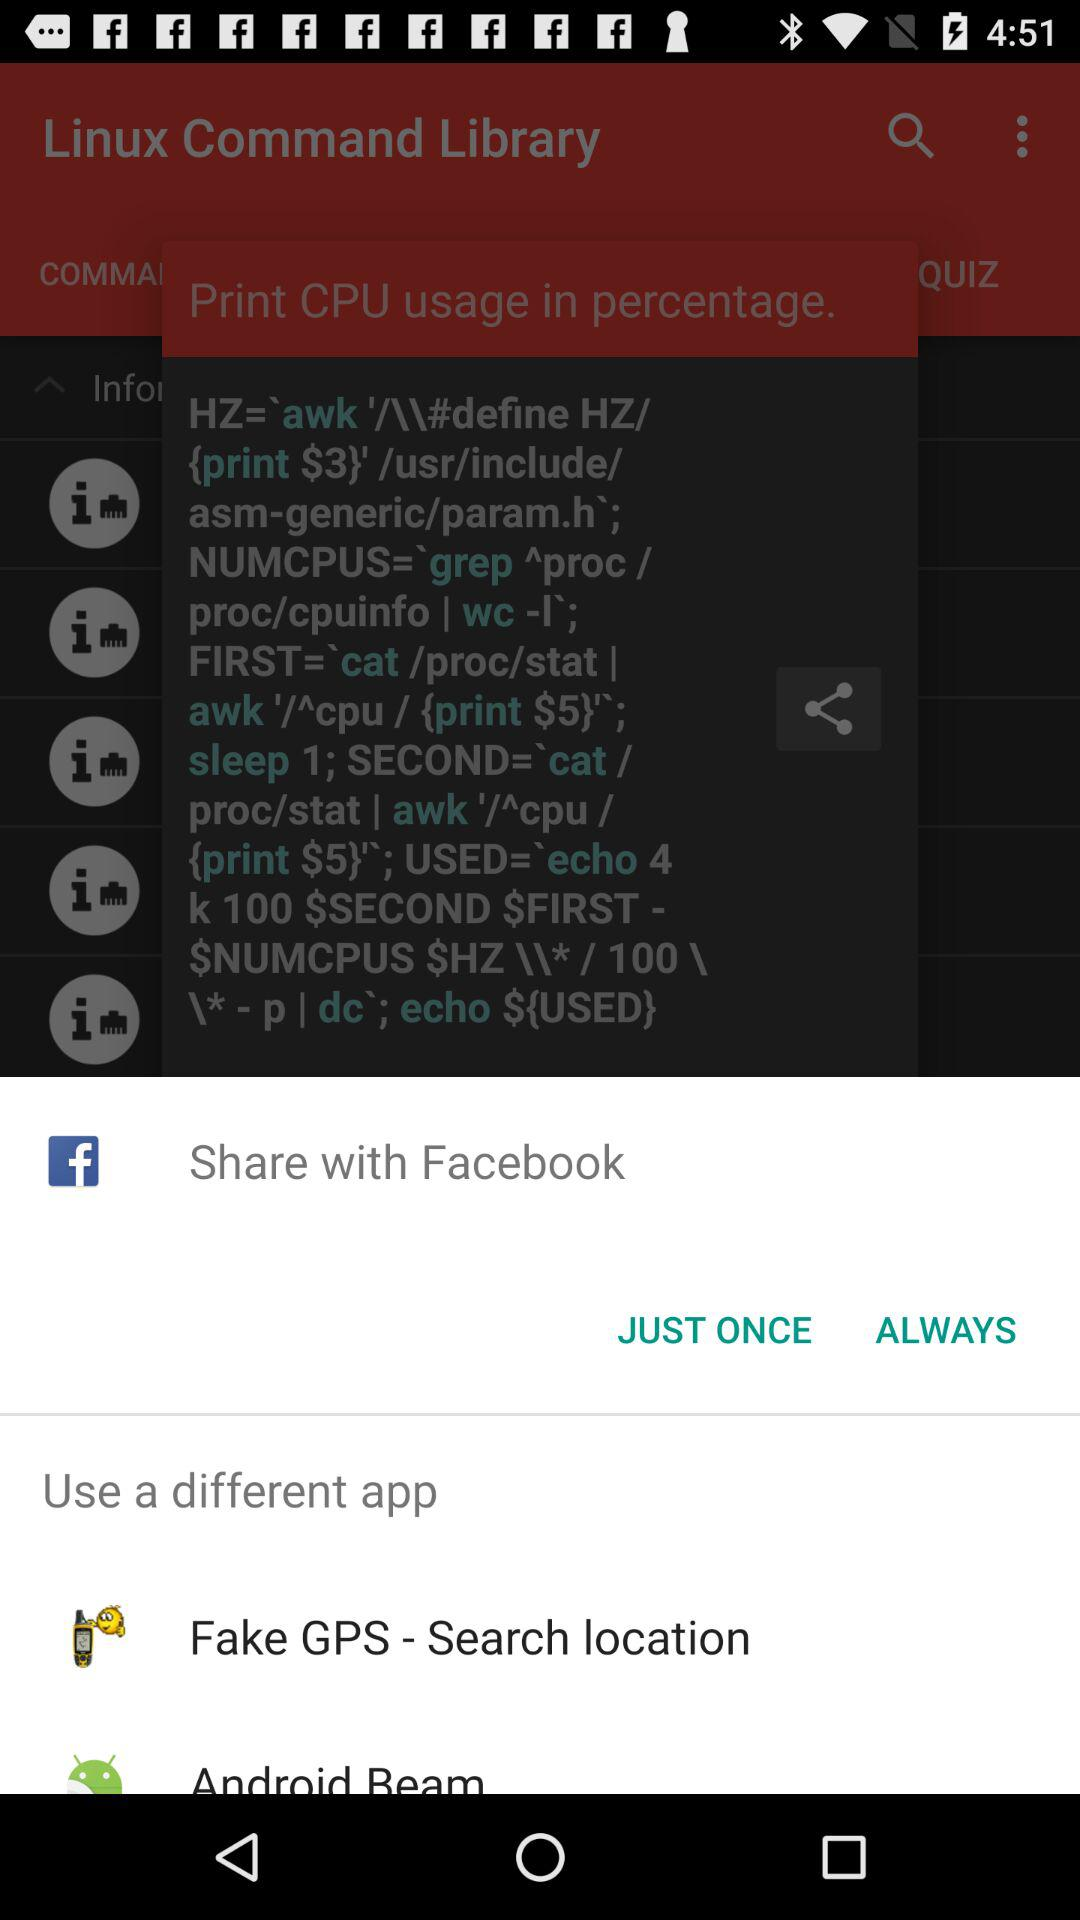From what apps can we share? The apps are "Facebook", "Fake GPS-Search location", and "Android Beam". 